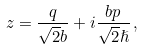Convert formula to latex. <formula><loc_0><loc_0><loc_500><loc_500>z = \frac { q } { \sqrt { 2 } b } + i \frac { b p } { \sqrt { 2 } \hslash } \, ,</formula> 